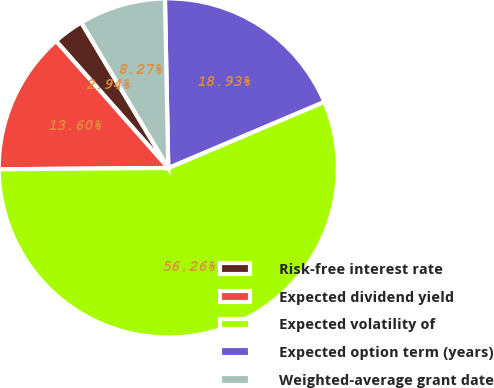Convert chart to OTSL. <chart><loc_0><loc_0><loc_500><loc_500><pie_chart><fcel>Risk-free interest rate<fcel>Expected dividend yield<fcel>Expected volatility of<fcel>Expected option term (years)<fcel>Weighted-average grant date<nl><fcel>2.94%<fcel>13.6%<fcel>56.25%<fcel>18.93%<fcel>8.27%<nl></chart> 